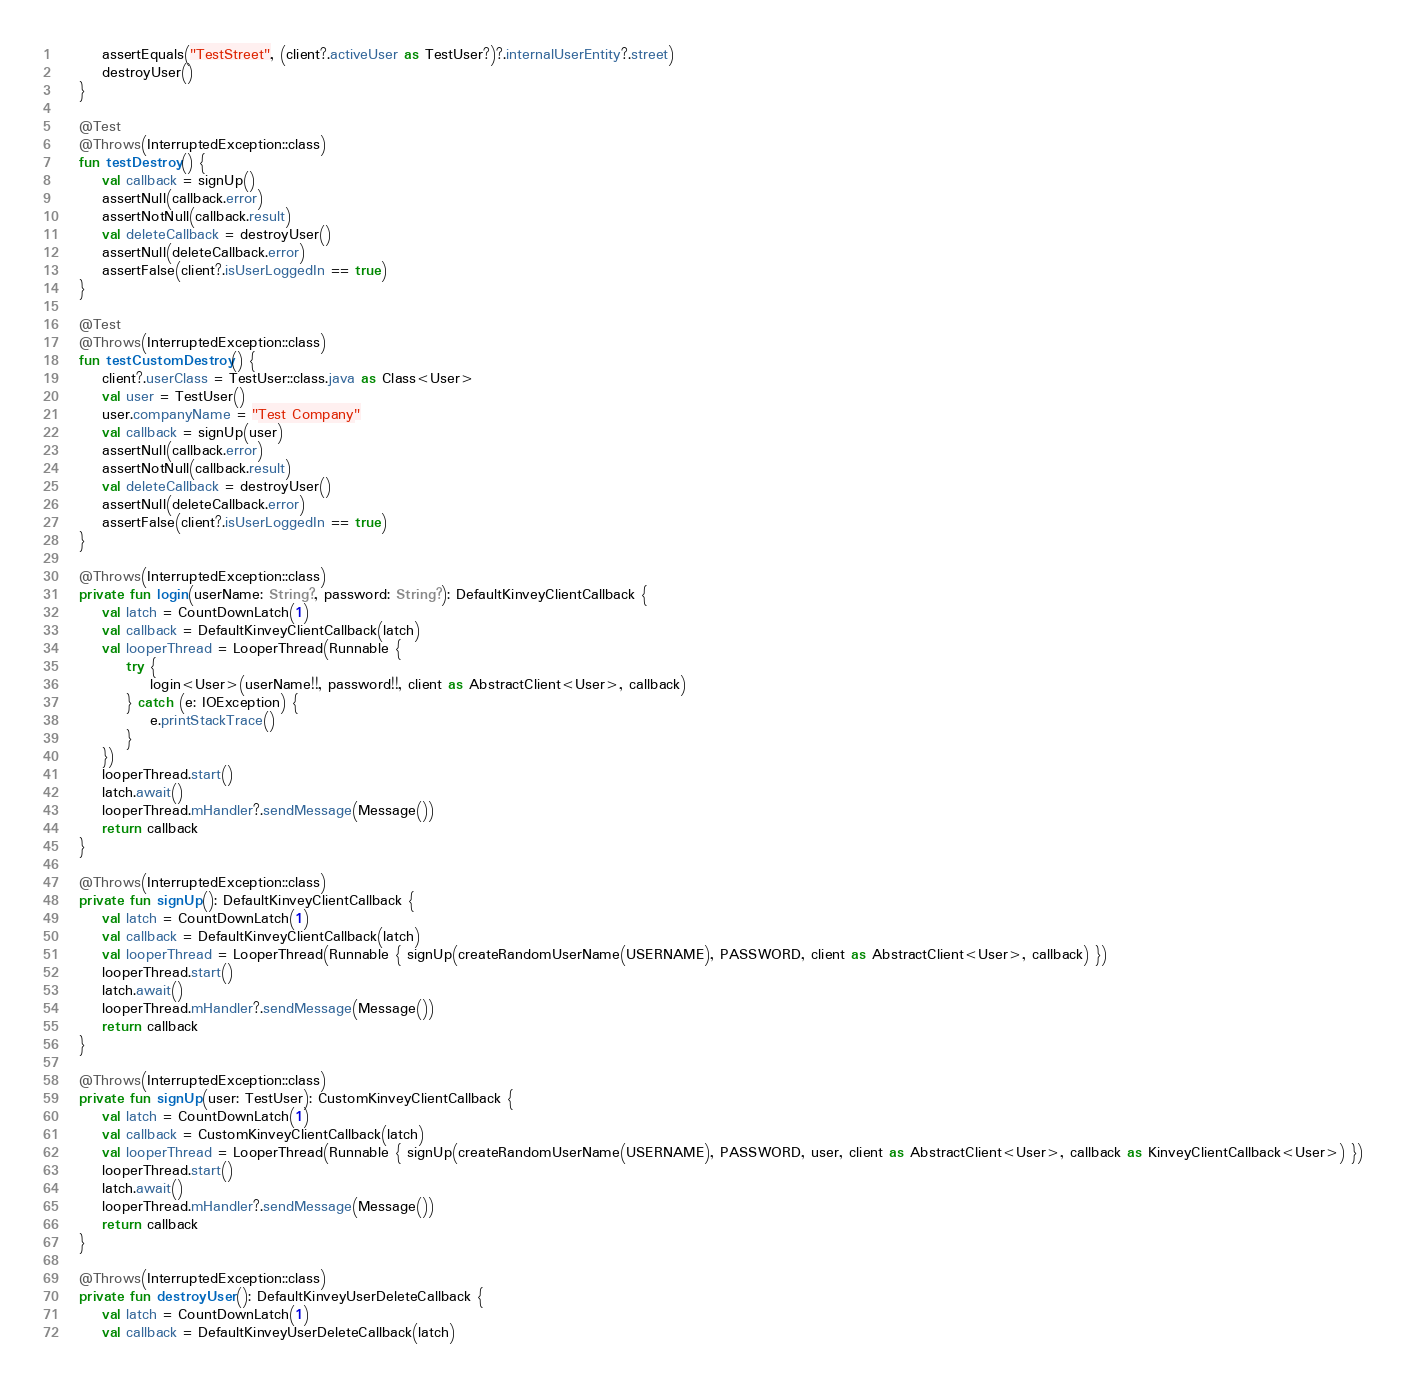Convert code to text. <code><loc_0><loc_0><loc_500><loc_500><_Kotlin_>        assertEquals("TestStreet", (client?.activeUser as TestUser?)?.internalUserEntity?.street)
        destroyUser()
    }

    @Test
    @Throws(InterruptedException::class)
    fun testDestroy() {
        val callback = signUp()
        assertNull(callback.error)
        assertNotNull(callback.result)
        val deleteCallback = destroyUser()
        assertNull(deleteCallback.error)
        assertFalse(client?.isUserLoggedIn == true)
    }

    @Test
    @Throws(InterruptedException::class)
    fun testCustomDestroy() {
        client?.userClass = TestUser::class.java as Class<User>
        val user = TestUser()
        user.companyName = "Test Company"
        val callback = signUp(user)
        assertNull(callback.error)
        assertNotNull(callback.result)
        val deleteCallback = destroyUser()
        assertNull(deleteCallback.error)
        assertFalse(client?.isUserLoggedIn == true)
    }

    @Throws(InterruptedException::class)
    private fun login(userName: String?, password: String?): DefaultKinveyClientCallback {
        val latch = CountDownLatch(1)
        val callback = DefaultKinveyClientCallback(latch)
        val looperThread = LooperThread(Runnable {
            try {
                login<User>(userName!!, password!!, client as AbstractClient<User>, callback)
            } catch (e: IOException) {
                e.printStackTrace()
            }
        })
        looperThread.start()
        latch.await()
        looperThread.mHandler?.sendMessage(Message())
        return callback
    }

    @Throws(InterruptedException::class)
    private fun signUp(): DefaultKinveyClientCallback {
        val latch = CountDownLatch(1)
        val callback = DefaultKinveyClientCallback(latch)
        val looperThread = LooperThread(Runnable { signUp(createRandomUserName(USERNAME), PASSWORD, client as AbstractClient<User>, callback) })
        looperThread.start()
        latch.await()
        looperThread.mHandler?.sendMessage(Message())
        return callback
    }

    @Throws(InterruptedException::class)
    private fun signUp(user: TestUser): CustomKinveyClientCallback {
        val latch = CountDownLatch(1)
        val callback = CustomKinveyClientCallback(latch)
        val looperThread = LooperThread(Runnable { signUp(createRandomUserName(USERNAME), PASSWORD, user, client as AbstractClient<User>, callback as KinveyClientCallback<User>) })
        looperThread.start()
        latch.await()
        looperThread.mHandler?.sendMessage(Message())
        return callback
    }

    @Throws(InterruptedException::class)
    private fun destroyUser(): DefaultKinveyUserDeleteCallback {
        val latch = CountDownLatch(1)
        val callback = DefaultKinveyUserDeleteCallback(latch)</code> 